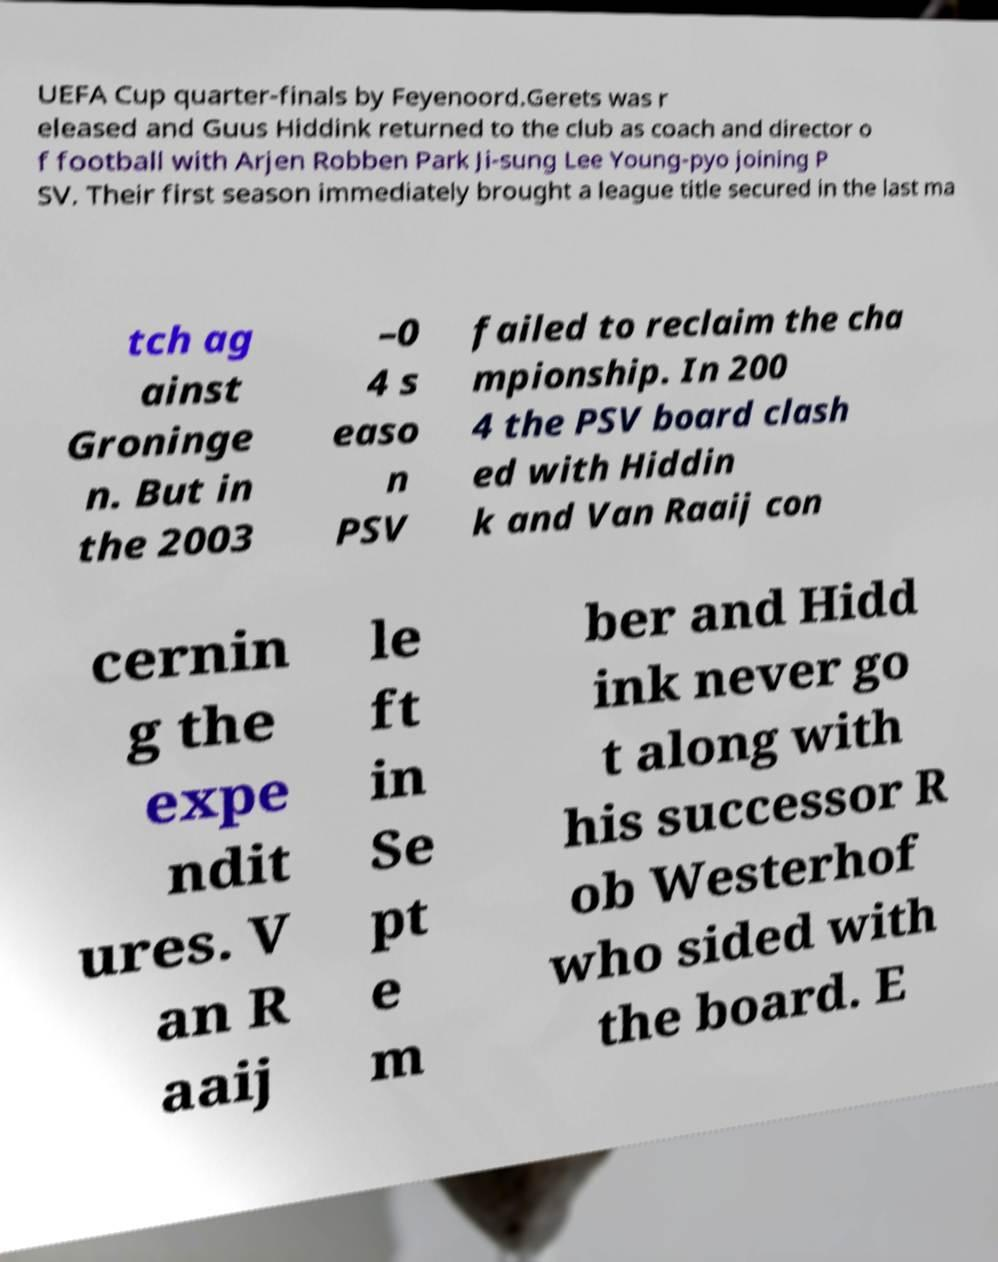Please identify and transcribe the text found in this image. UEFA Cup quarter-finals by Feyenoord.Gerets was r eleased and Guus Hiddink returned to the club as coach and director o f football with Arjen Robben Park Ji-sung Lee Young-pyo joining P SV. Their first season immediately brought a league title secured in the last ma tch ag ainst Groninge n. But in the 2003 –0 4 s easo n PSV failed to reclaim the cha mpionship. In 200 4 the PSV board clash ed with Hiddin k and Van Raaij con cernin g the expe ndit ures. V an R aaij le ft in Se pt e m ber and Hidd ink never go t along with his successor R ob Westerhof who sided with the board. E 